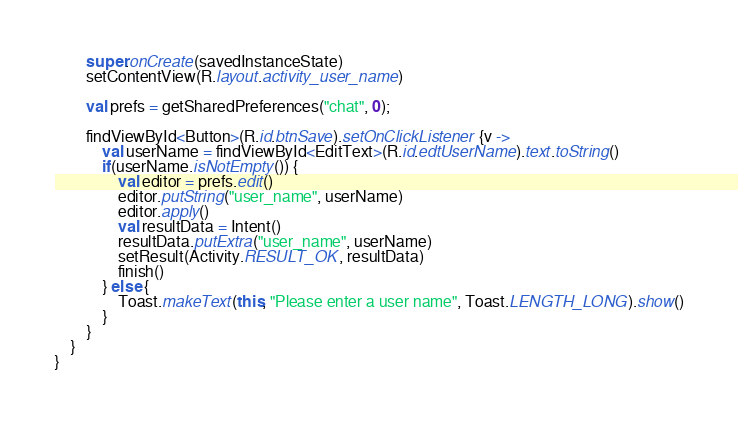<code> <loc_0><loc_0><loc_500><loc_500><_Kotlin_>        super.onCreate(savedInstanceState)
        setContentView(R.layout.activity_user_name)

        val prefs = getSharedPreferences("chat", 0);

        findViewById<Button>(R.id.btnSave).setOnClickListener {v ->
            val userName = findViewById<EditText>(R.id.edtUserName).text.toString()
            if(userName.isNotEmpty()) {
                val editor = prefs.edit()
                editor.putString("user_name", userName)
                editor.apply()
                val resultData = Intent()
                resultData.putExtra("user_name", userName)
                setResult(Activity.RESULT_OK, resultData)
                finish()
            } else {
                Toast.makeText(this, "Please enter a user name", Toast.LENGTH_LONG).show()
            }
        }
    }
}</code> 